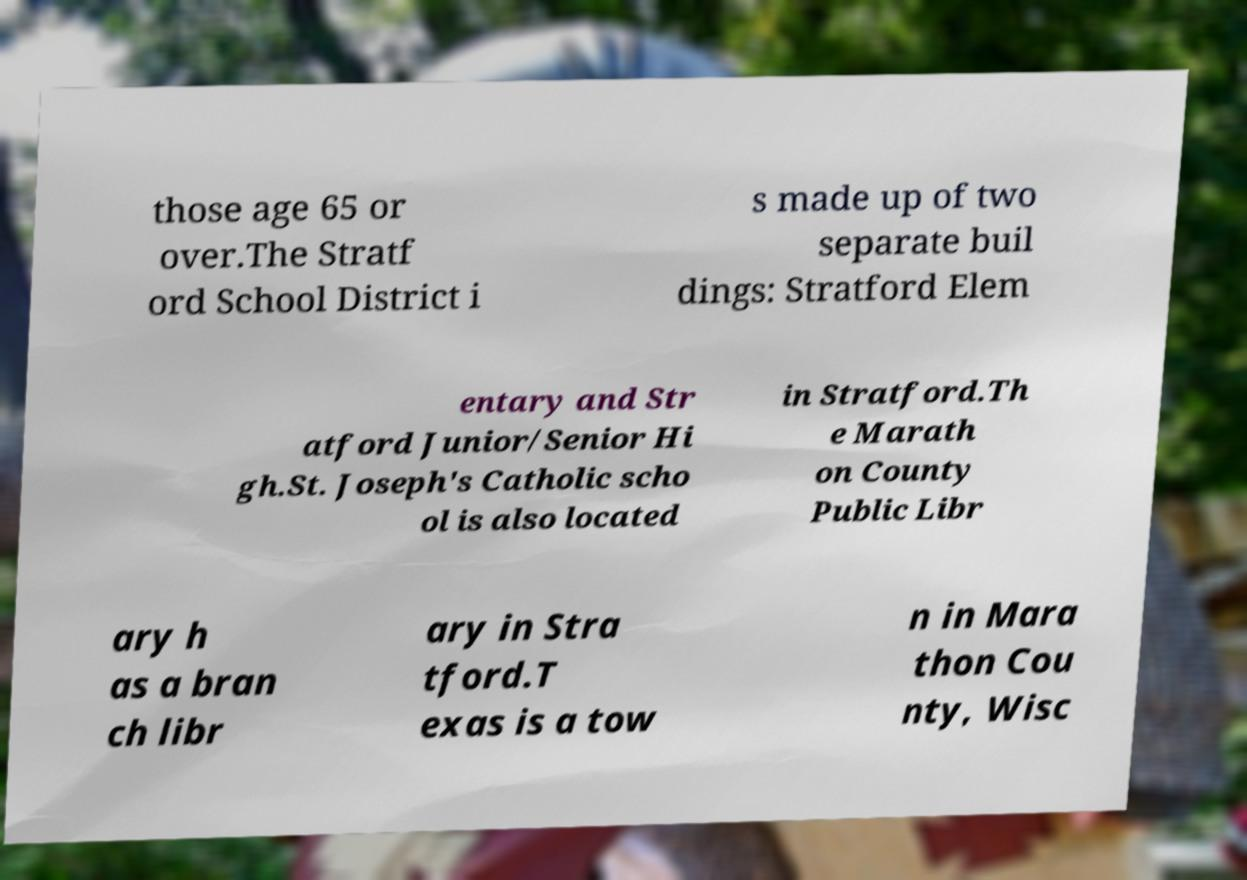What messages or text are displayed in this image? I need them in a readable, typed format. those age 65 or over.The Stratf ord School District i s made up of two separate buil dings: Stratford Elem entary and Str atford Junior/Senior Hi gh.St. Joseph's Catholic scho ol is also located in Stratford.Th e Marath on County Public Libr ary h as a bran ch libr ary in Stra tford.T exas is a tow n in Mara thon Cou nty, Wisc 